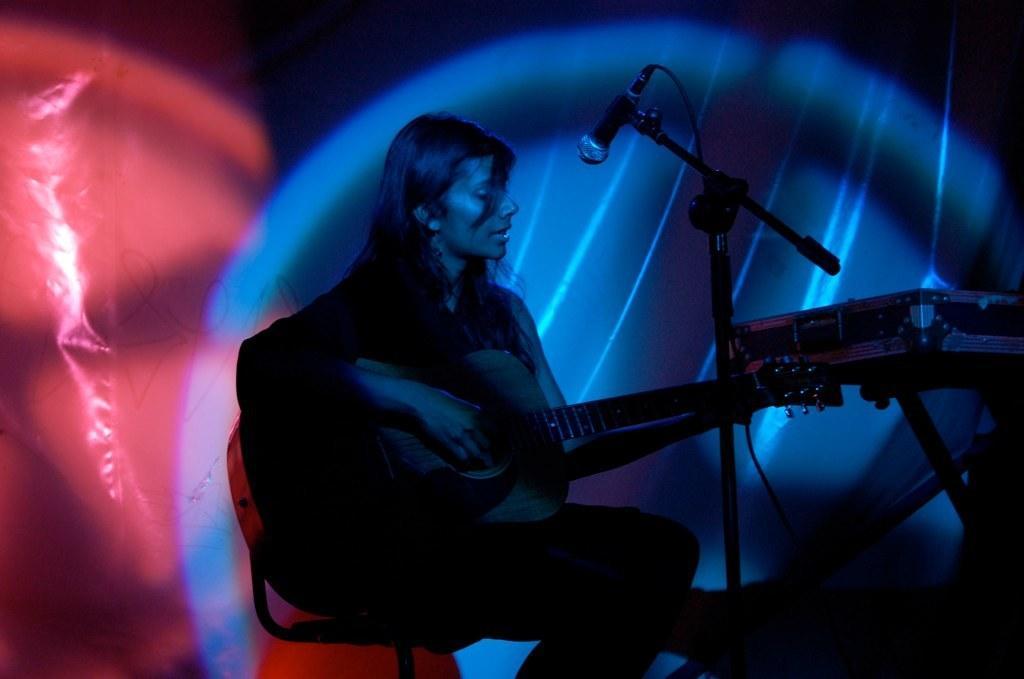Please provide a concise description of this image. In the image we can see there is a woman who is sitting on chair and holding guitar in her hand and there is a mic with a stand and on stand there is a box. 